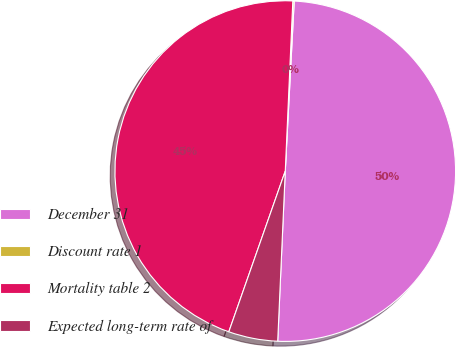Convert chart. <chart><loc_0><loc_0><loc_500><loc_500><pie_chart><fcel>December 31<fcel>Discount rate 1<fcel>Mortality table 2<fcel>Expected long-term rate of<nl><fcel>49.87%<fcel>0.13%<fcel>45.33%<fcel>4.67%<nl></chart> 